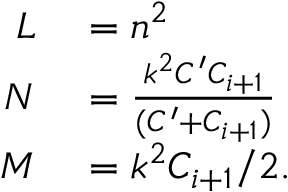<formula> <loc_0><loc_0><loc_500><loc_500>\begin{array} { r l } { L } & = n ^ { 2 } } \\ { N } & = \frac { k ^ { 2 } C ^ { \prime } C _ { i + 1 } } { ( C ^ { \prime } + C _ { i + 1 } ) } } \\ { M } & = k ^ { 2 } C _ { i + 1 } / 2 . } \end{array}</formula> 